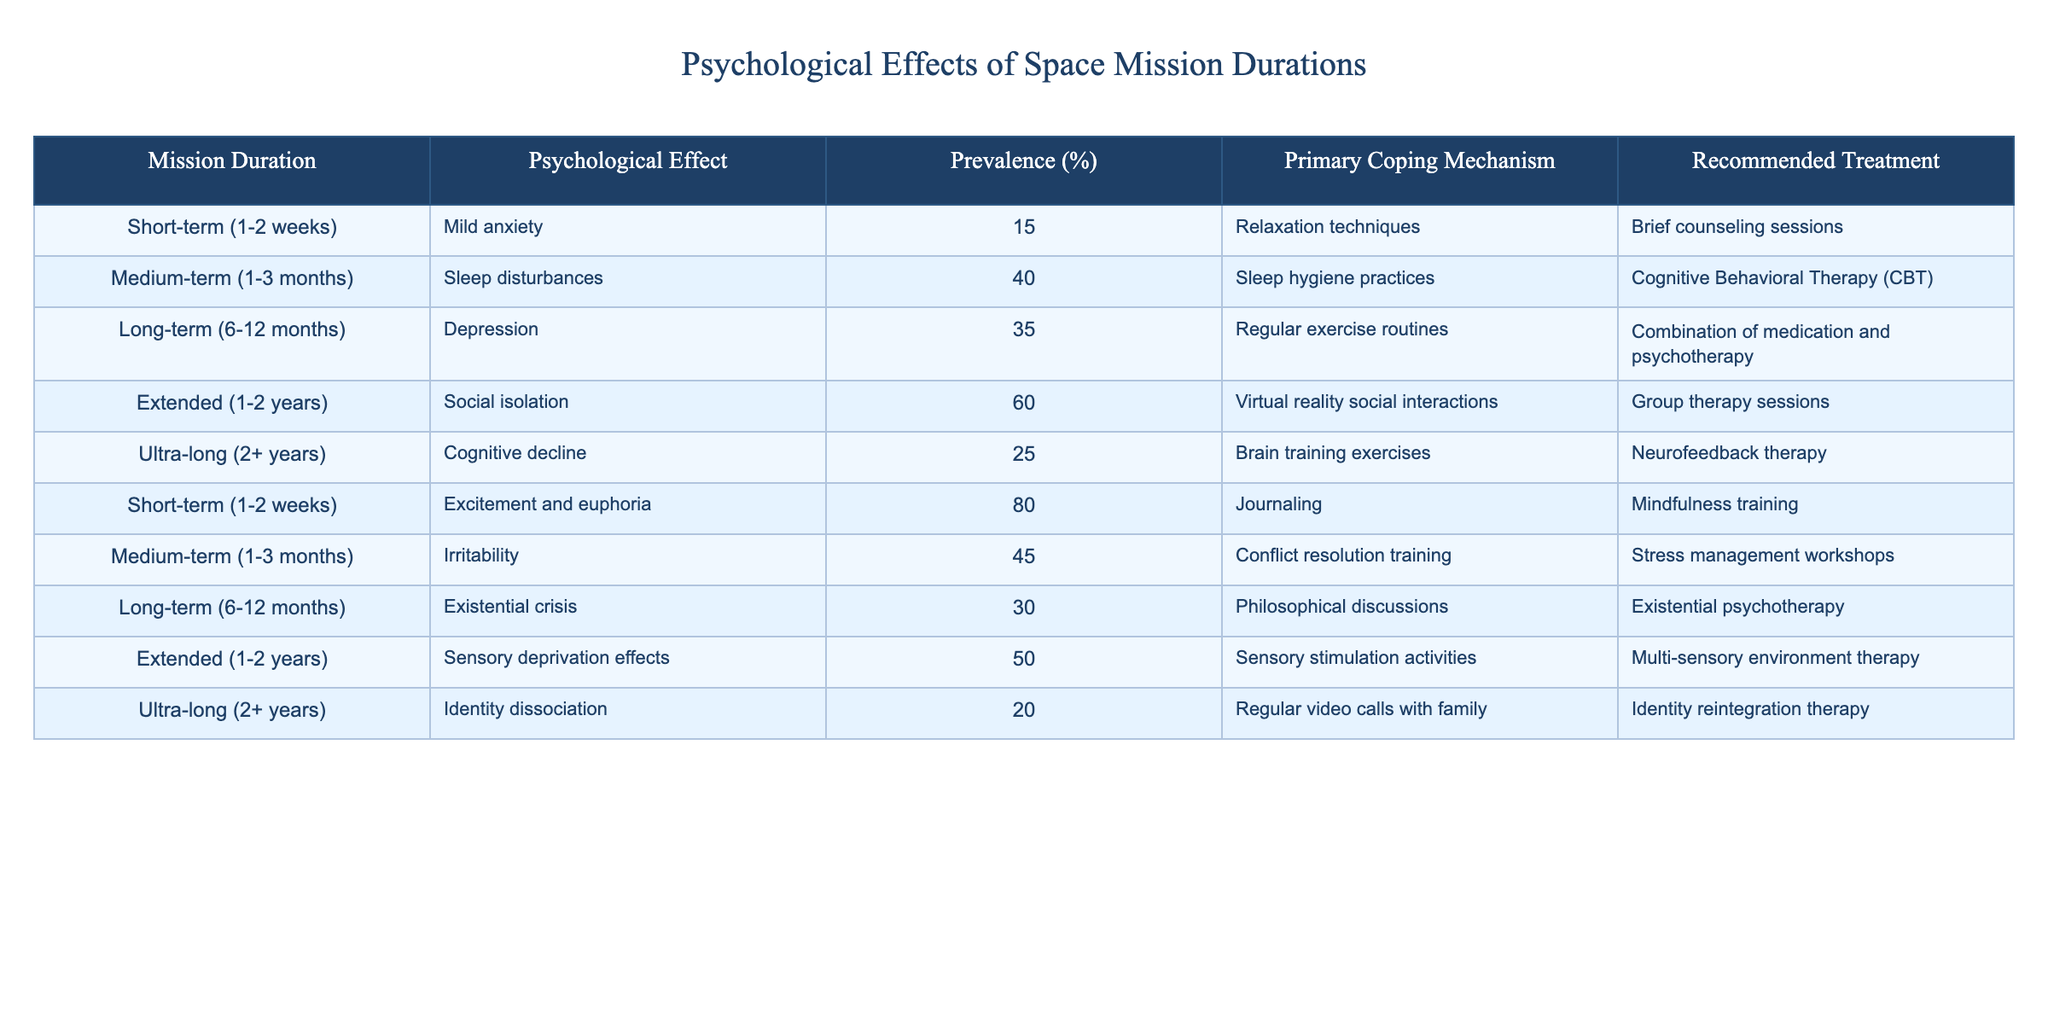What psychological effect has the highest prevalence in extended space missions? Referring to the table, in the row for extended missions (1-2 years), social isolation has a prevalence of 60%, which is the highest compared to other effects listed.
Answer: 60% What is the primary coping mechanism for sleep disturbances during medium-term missions? According to the table, for medium-term missions (1-3 months), the primary coping mechanism for sleep disturbances is sleep hygiene practices.
Answer: Sleep hygiene practices What percentage of astronauts experience excitement and euphoria during short-term missions? In the table, under short-term missions (1-2 weeks), 80% of astronauts experience excitement and euphoria.
Answer: 80% Which psychological effect has the lowest percentage during ultra-long missions? Looking at the table, the psychological effect of identity dissociation occurs at 20% among ultra-long missions (2+ years), making it the lowest in that category.
Answer: 20% What is the difference in prevalence of sensory deprivation effects between extended and ultra-long missions? In the table, sensory deprivation effects have a prevalence of 50% during extended missions (1-2 years) and 25% during ultra-long missions (2+ years). The difference is 50% - 25% = 25%.
Answer: 25% Is there any mechanism recommended for dealing with existential crises during long-term missions? The table indicates that existential crises, which is a psychological effect noted in long-term missions (6-12 months), does indeed have a recommended treatment, which is existential psychotherapy.
Answer: Yes What psychological effects have a prevalence of 30% or less? Reviewing the table, there are two effects with a prevalence of 30% or less: cognitive decline with 25% and identity dissociation with 20%.
Answer: 25% and 20% Which coping mechanism is suggested for addressing irritability in medium-term missions? According to the table, a suggested coping mechanism for irritability experienced during medium-term missions (1-3 months) is conflict resolution training.
Answer: Conflict resolution training Are there any recommended treatments for the psychological effects arising from short-term missions? Yes, the table offers recommended treatments for effects arising from short-term missions, including brief counseling sessions for mild anxiety and mindfulness training for excitement and euphoria.
Answer: Yes 